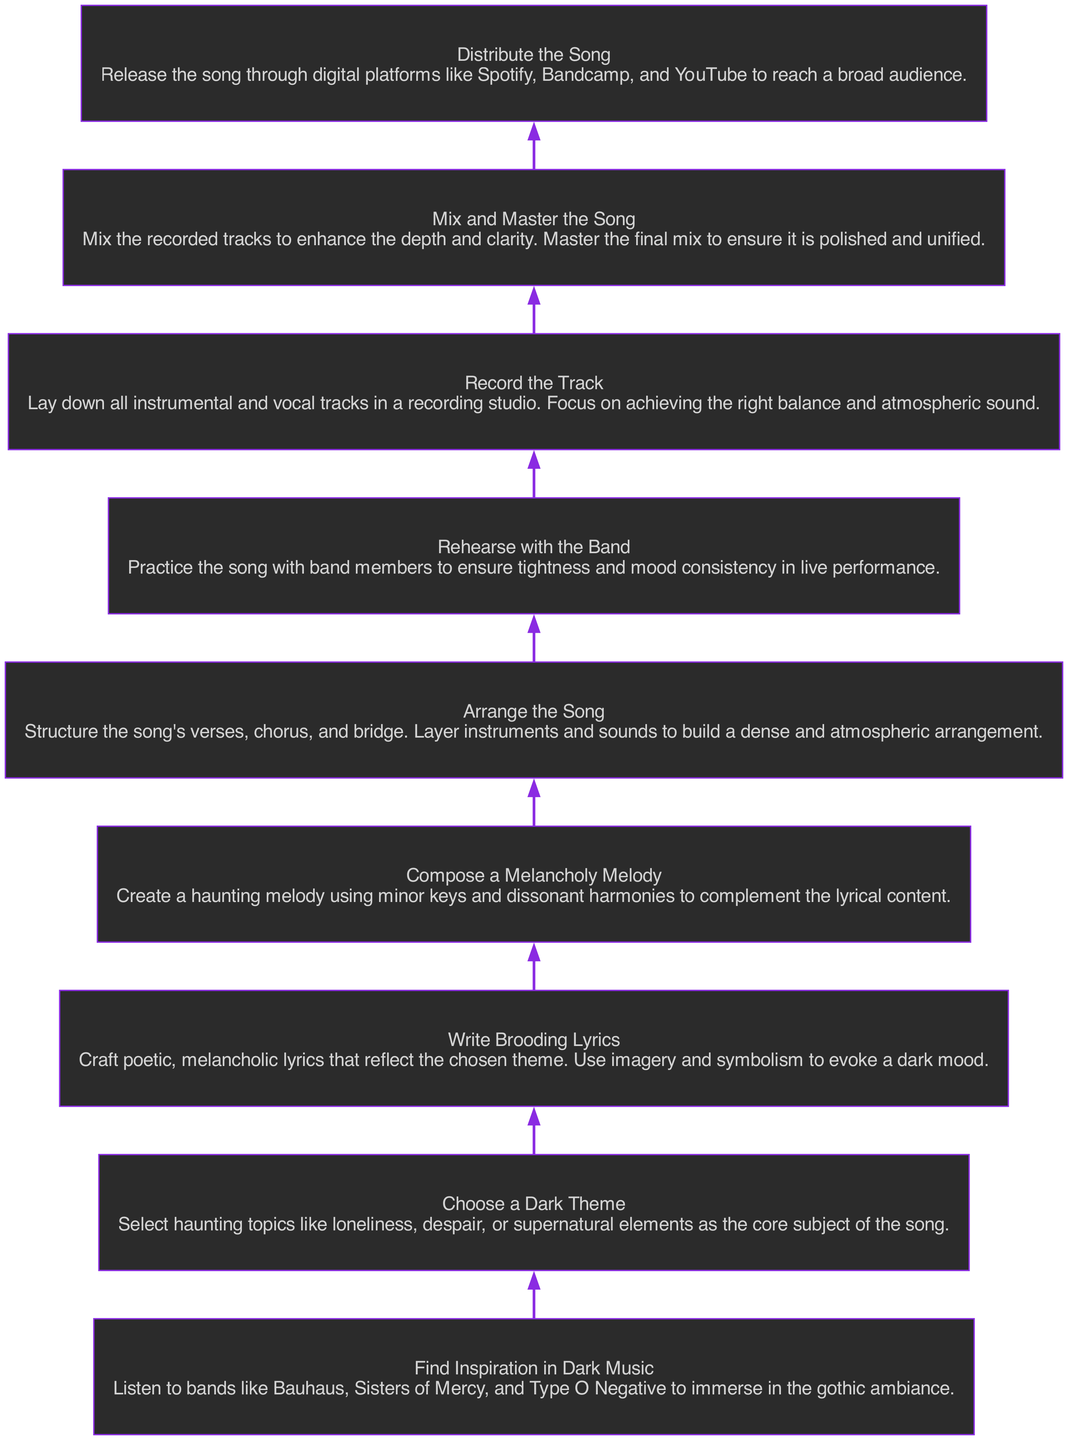What is the first step in the process? The first step in the process is identified as "Find Inspiration in Dark Music," which is the bottom node of the diagram.
Answer: Find Inspiration in Dark Music How many steps are there in total? There are a total of eight steps in the process, from "Find Inspiration in Dark Music" to "Distribute the Song." Counting each node gives us this total.
Answer: Eight What theme is suggested for the song? The suggested theme for the song is "dark theme," specifically referencing topics like loneliness and despair. This is described in the step immediately after finding inspiration.
Answer: Choose a Dark Theme Which step comes before recording? The step that comes directly before "Record the Track" is "Rehearse with the Band." This can be found by following the flow upwards from the recording node.
Answer: Rehearse with the Band Which two elements are directly connected? The two directly connected elements are "Compose a Melancholy Melody" and "Write Brooding Lyrics." The diagram shows a direct edge from the lyrics step to the melody step.
Answer: Compose a Melancholy Melody and Write Brooding Lyrics What type of lyrics should be written? The type of lyrics that should be written are described as "brooding," which emphasizes the poetic and melancholic nature suitable for this style of music.
Answer: Brooding Lyrics What is the last action in the process? The last action in the process is "Distribute the Song," which is the topmost node in the diagram. This indicates the final step after all preparations are complete.
Answer: Distribute the Song What should the final mix achieve? The final mix should achieve a "polished and unified" sound, as mentioned in the "Mix and Master the Song" step. This goal is essential for the overall production quality.
Answer: Polished and Unified What type of melody is to be composed? The melody to be composed should be a "melancholy melody," characterized by minor keys and dissonant harmonies. This reflects the dark aesthetic intended for the song.
Answer: Melancholy Melody 